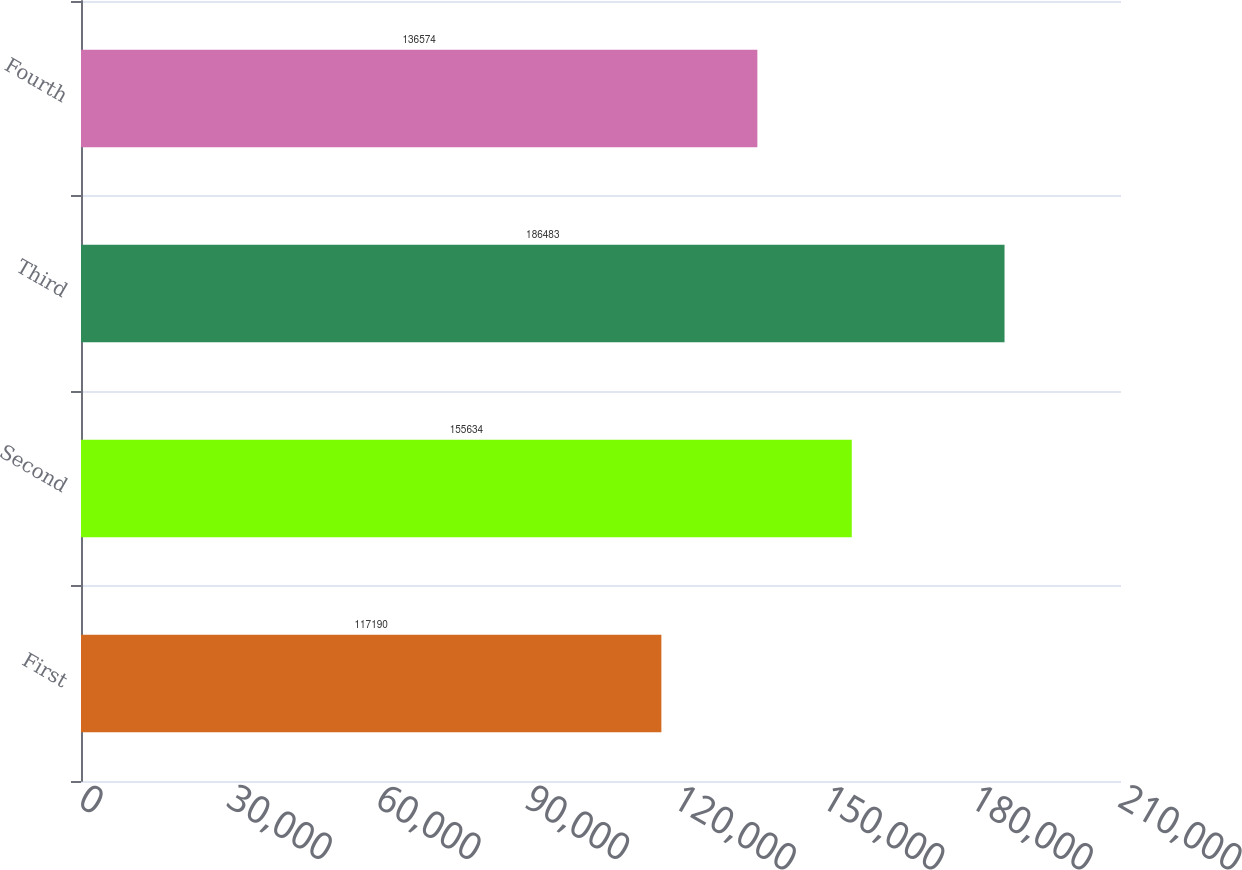<chart> <loc_0><loc_0><loc_500><loc_500><bar_chart><fcel>First<fcel>Second<fcel>Third<fcel>Fourth<nl><fcel>117190<fcel>155634<fcel>186483<fcel>136574<nl></chart> 